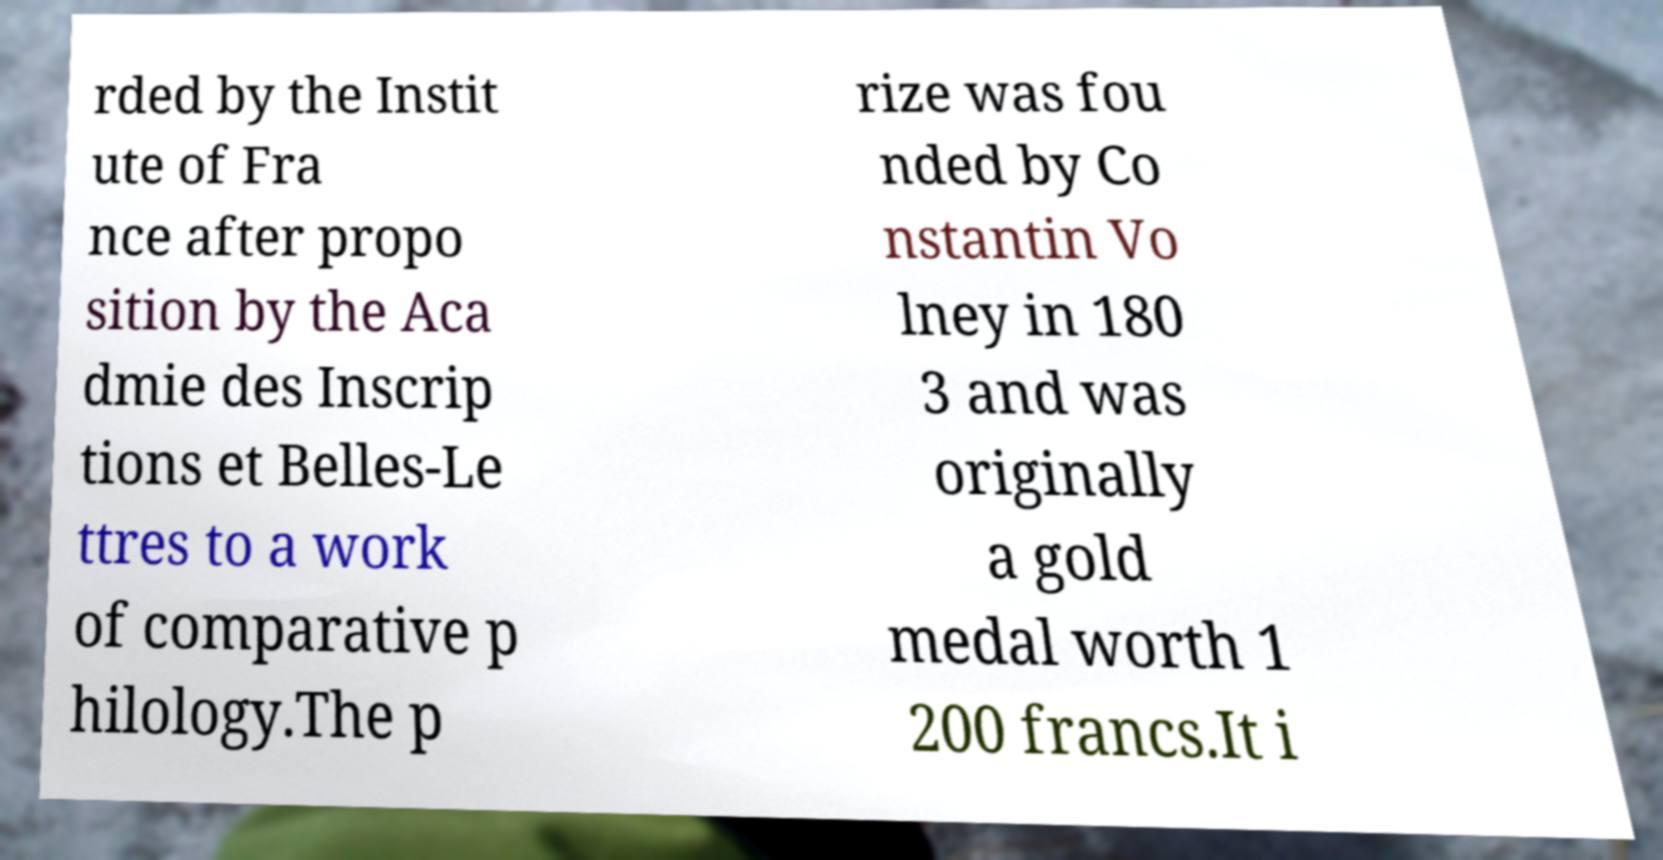Can you accurately transcribe the text from the provided image for me? rded by the Instit ute of Fra nce after propo sition by the Aca dmie des Inscrip tions et Belles-Le ttres to a work of comparative p hilology.The p rize was fou nded by Co nstantin Vo lney in 180 3 and was originally a gold medal worth 1 200 francs.It i 